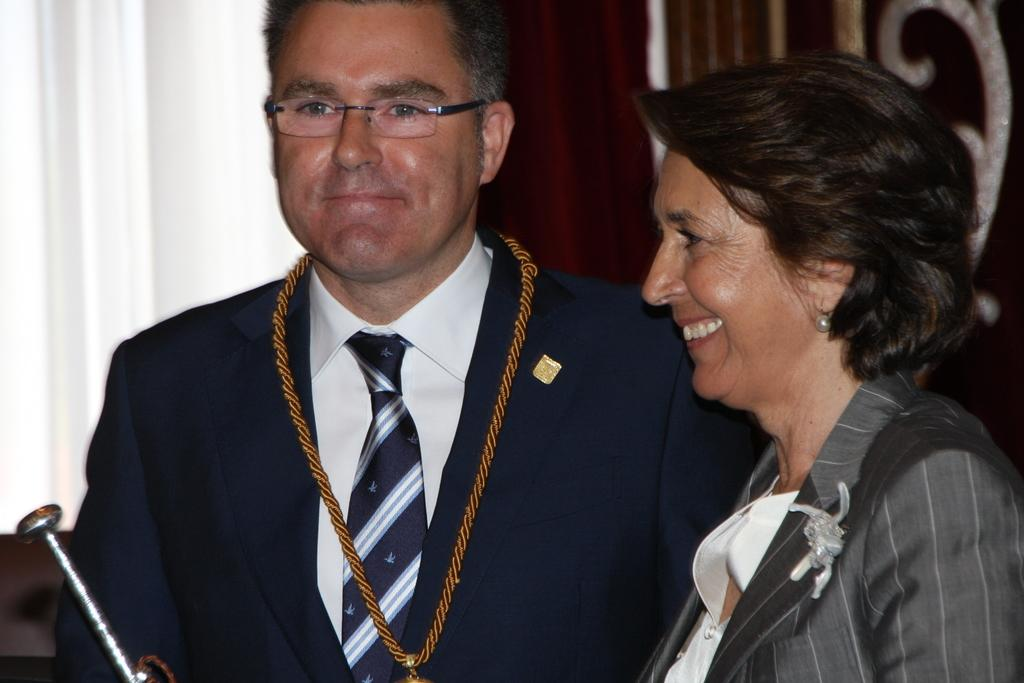How many people are present in the image? There are four people in the image. Can you describe the positioning of the people in the image? One person is standing in the middle of the group, and one person is standing on the right side of the group. What type of club can be seen in the hands of the person standing on the left side of the group? There is no club visible in the hands of any person in the image. 